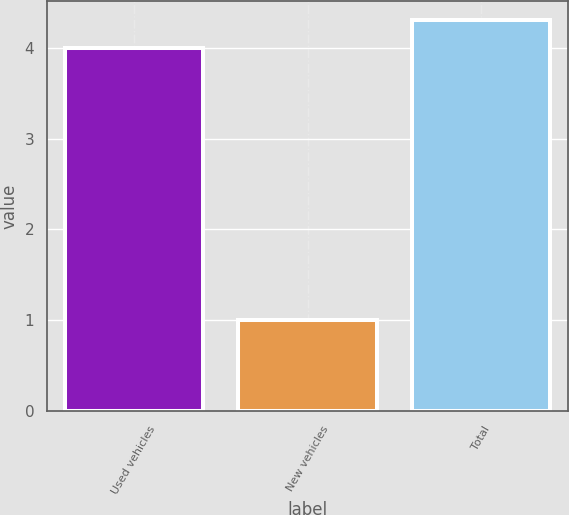Convert chart. <chart><loc_0><loc_0><loc_500><loc_500><bar_chart><fcel>Used vehicles<fcel>New vehicles<fcel>Total<nl><fcel>4<fcel>1<fcel>4.3<nl></chart> 